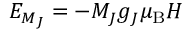Convert formula to latex. <formula><loc_0><loc_0><loc_500><loc_500>E _ { M _ { J } } = - M _ { J } g _ { J } \mu _ { B } H</formula> 